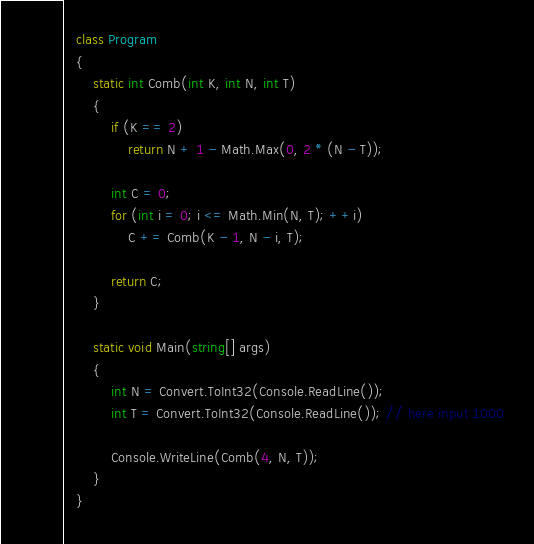<code> <loc_0><loc_0><loc_500><loc_500><_C#_>   class Program
   {
       static int Comb(int K, int N, int T)
       {
           if (K == 2)
               return N + 1 - Math.Max(0, 2 * (N - T));

           int C = 0;
           for (int i = 0; i <= Math.Min(N, T); ++i)
               C += Comb(K - 1, N - i, T);

           return C;
       }

       static void Main(string[] args)
       {
           int N = Convert.ToInt32(Console.ReadLine());
           int T = Convert.ToInt32(Console.ReadLine()); // here input 1000

           Console.WriteLine(Comb(4, N, T));
       }
   }</code> 